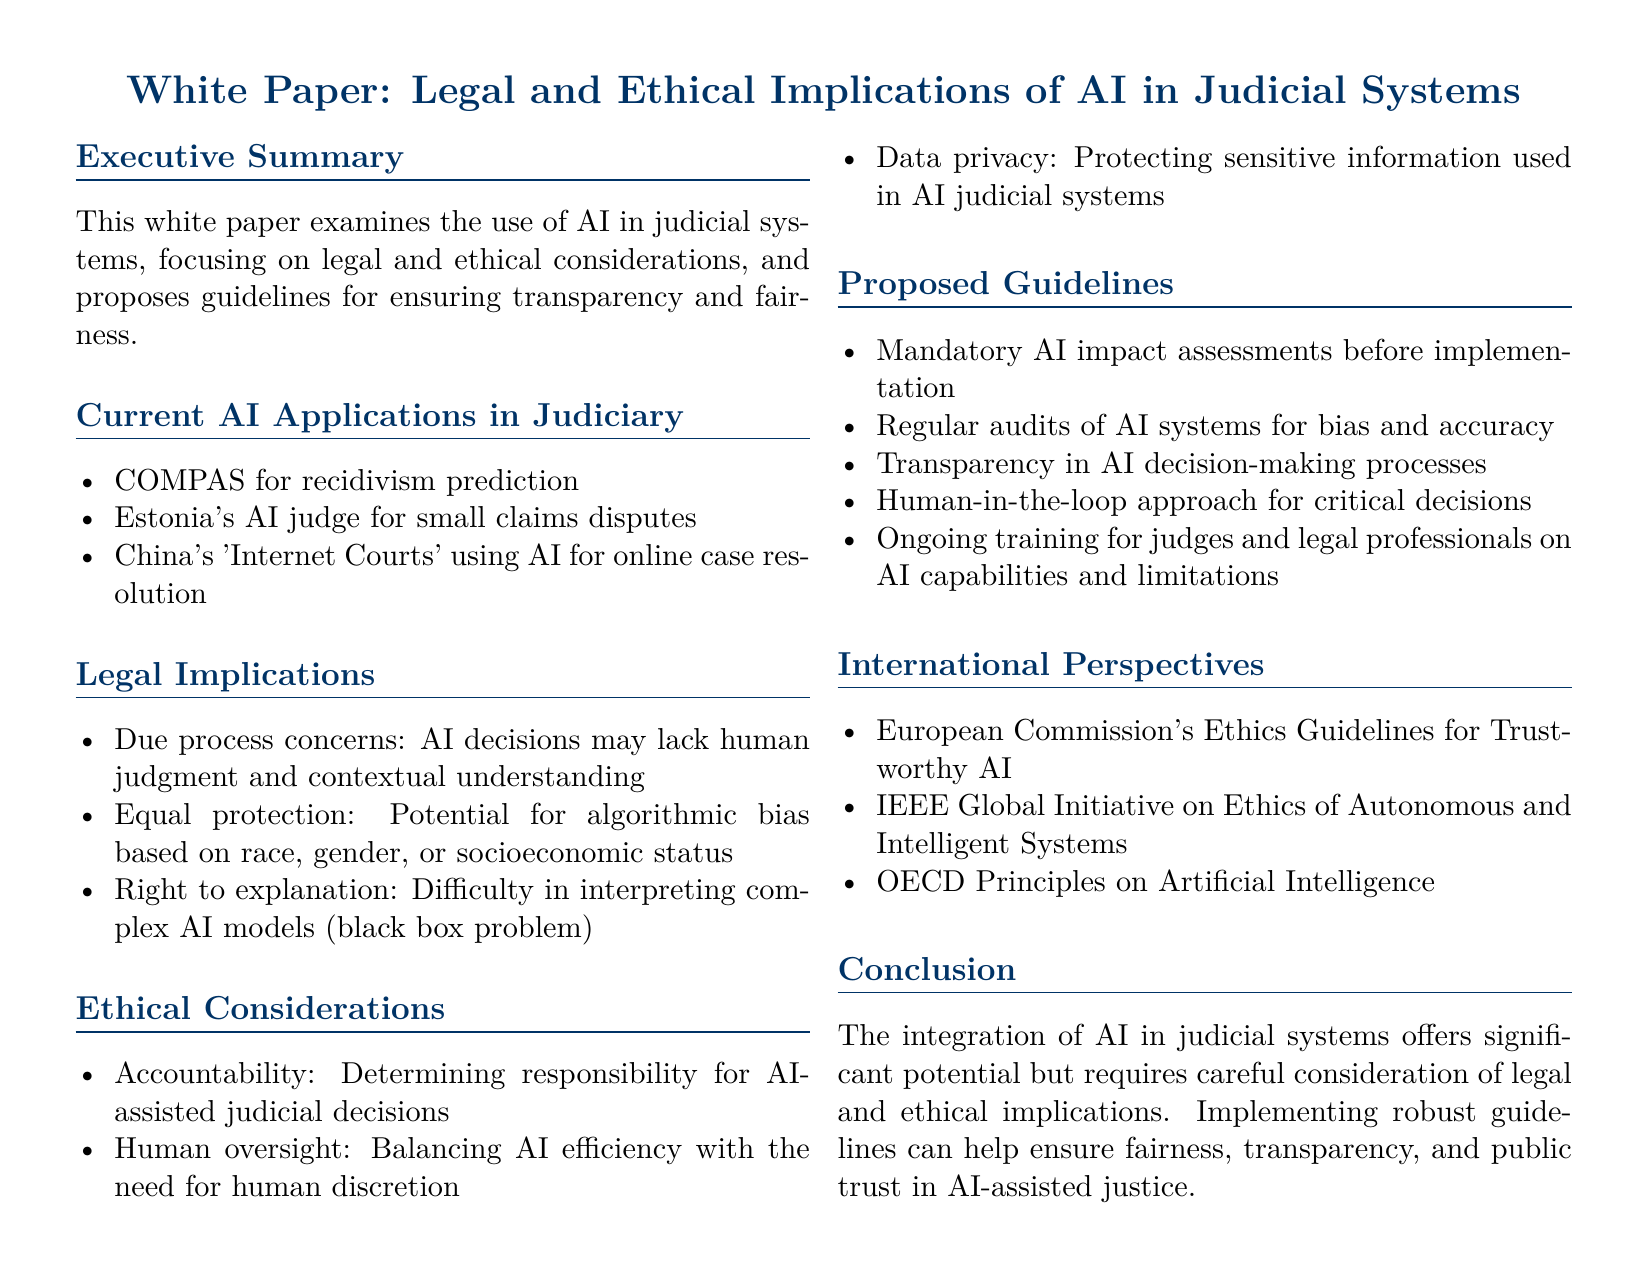What is the title of the document? The title is introduced at the start of the document and summarizes its focus on legal and ethical implications of AI in judicial systems.
Answer: White Paper: Legal and Ethical Implications of AI in Judicial Systems What AI application is used for recidivism prediction? The document lists specific applications of AI in the judiciary, such as COMPAS for recidivism prediction.
Answer: COMPAS What are potential algorithmic biases mentioned in the legal implications? The document highlights specific biases that AI systems might perpetuate, such as those based on race, gender, or socioeconomic status.
Answer: Race, gender, or socioeconomic status How many guidelines are proposed in the document? The document outlines a series of guidelines for the use of AI in judicial systems and lists them.
Answer: Five What approach is suggested for critical AI-assisted decisions? A specific methodology is proposed to ensure human involvement in decision-making processes where AI is utilized.
Answer: Human-in-the-loop Which international entity's guidelines are cited in the document? The document references notable international perspectives and organizations regarding AI ethics.
Answer: European Commission's Ethics Guidelines for Trustworthy AI What is a key ethical consideration highlighted in the document? The document emphasizes the importance of accountability in AI-assisted judicial decisions as a significant ethical issue.
Answer: Accountability What does the conclusion emphasize regarding AI integration in justice? The conclusion summarizes the overarching concern addressed throughout the document regarding the introduction of AI in judicial frameworks.
Answer: Careful consideration of legal and ethical implications 